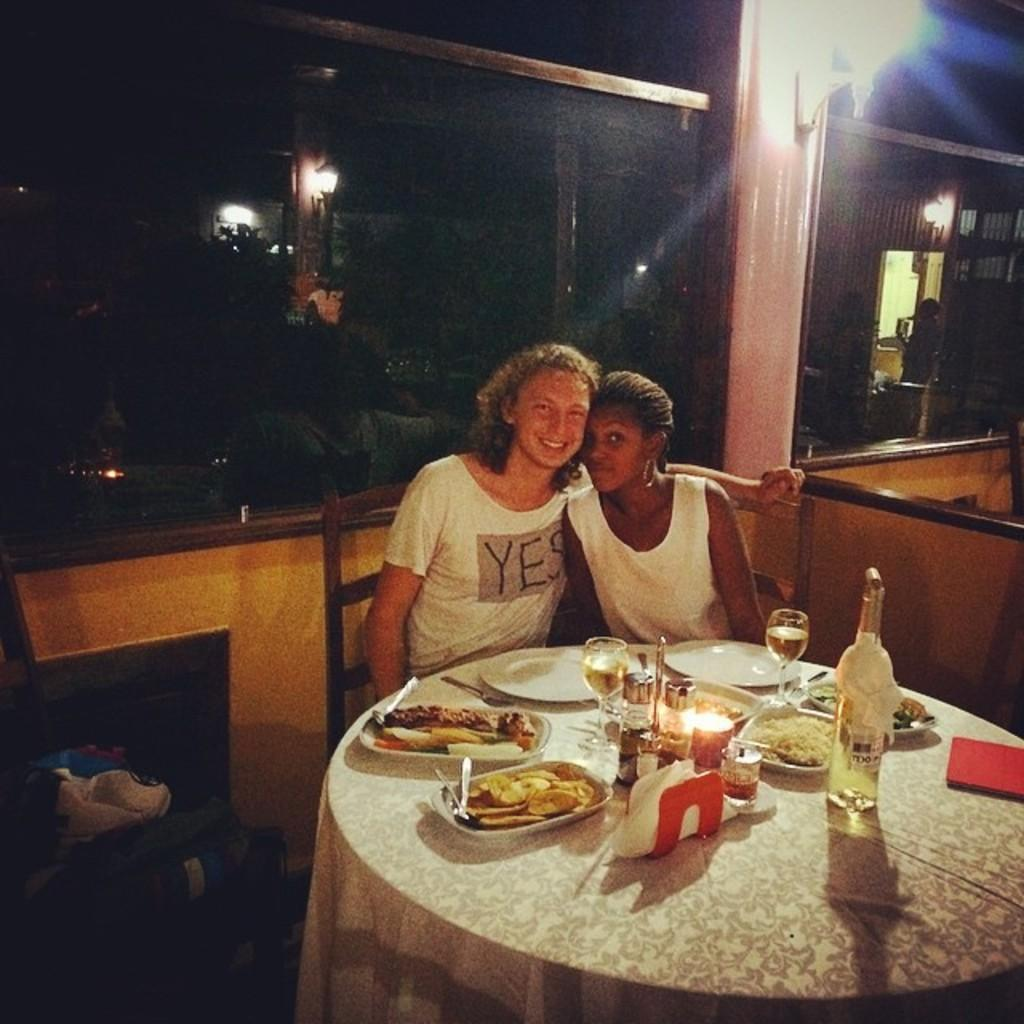How many women are sitting in the image? There are two women sitting on chairs in the image. What is on the table in the image? There are food items, a vodka bottle, and wine glasses on the table. What type of string is being used to tie the toad to the chair in the image? There is no toad or string present in the image. 